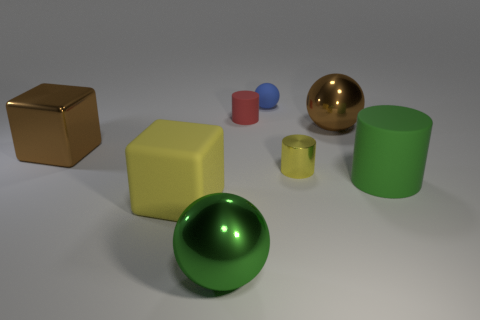There is a big brown thing that is on the right side of the rubber cylinder that is behind the tiny yellow object; what shape is it?
Your answer should be compact. Sphere. Is there a small red object made of the same material as the blue ball?
Your answer should be compact. Yes. What color is the other metal thing that is the same shape as the large yellow thing?
Make the answer very short. Brown. Is the number of large cylinders behind the brown ball less than the number of small yellow metal cylinders behind the large green rubber cylinder?
Offer a very short reply. Yes. What number of other things are the same shape as the green metal object?
Your answer should be compact. 2. Are there fewer small matte cylinders that are on the right side of the tiny matte cylinder than metal cylinders?
Provide a succinct answer. Yes. There is a green object to the right of the tiny blue rubber object; what material is it?
Provide a short and direct response. Rubber. What number of other things are the same size as the metallic cube?
Ensure brevity in your answer.  4. Is the number of large matte cylinders less than the number of cyan objects?
Your response must be concise. No. What is the shape of the red thing?
Your answer should be very brief. Cylinder. 